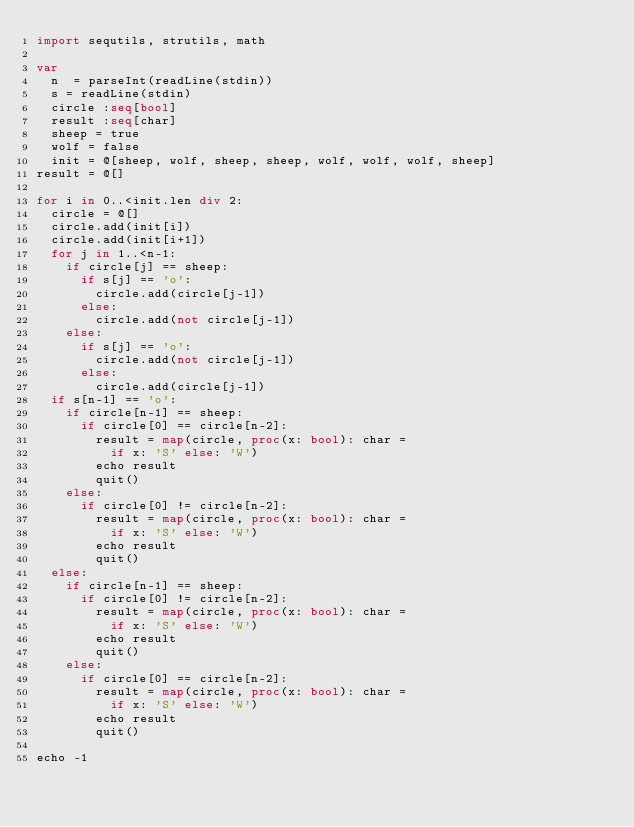<code> <loc_0><loc_0><loc_500><loc_500><_Nim_>import sequtils, strutils, math

var
  n  = parseInt(readLine(stdin))
  s = readLine(stdin)
  circle :seq[bool]
  result :seq[char]
  sheep = true
  wolf = false
  init = @[sheep, wolf, sheep, sheep, wolf, wolf, wolf, sheep]
result = @[]

for i in 0..<init.len div 2:
  circle = @[]
  circle.add(init[i])
  circle.add(init[i+1])
  for j in 1..<n-1:
    if circle[j] == sheep:
      if s[j] == 'o':
        circle.add(circle[j-1])
      else:
        circle.add(not circle[j-1])
    else:
      if s[j] == 'o':
        circle.add(not circle[j-1])
      else:
        circle.add(circle[j-1])
  if s[n-1] == 'o':
    if circle[n-1] == sheep:
      if circle[0] == circle[n-2]:
        result = map(circle, proc(x: bool): char =
          if x: 'S' else: 'W')
        echo result
        quit()
    else:
      if circle[0] != circle[n-2]:
        result = map(circle, proc(x: bool): char =
          if x: 'S' else: 'W')
        echo result
        quit()
  else:
    if circle[n-1] == sheep:
      if circle[0] != circle[n-2]:
        result = map(circle, proc(x: bool): char =
          if x: 'S' else: 'W')
        echo result
        quit()
    else:
      if circle[0] == circle[n-2]:
        result = map(circle, proc(x: bool): char =
          if x: 'S' else: 'W')
        echo result
        quit()

echo -1</code> 